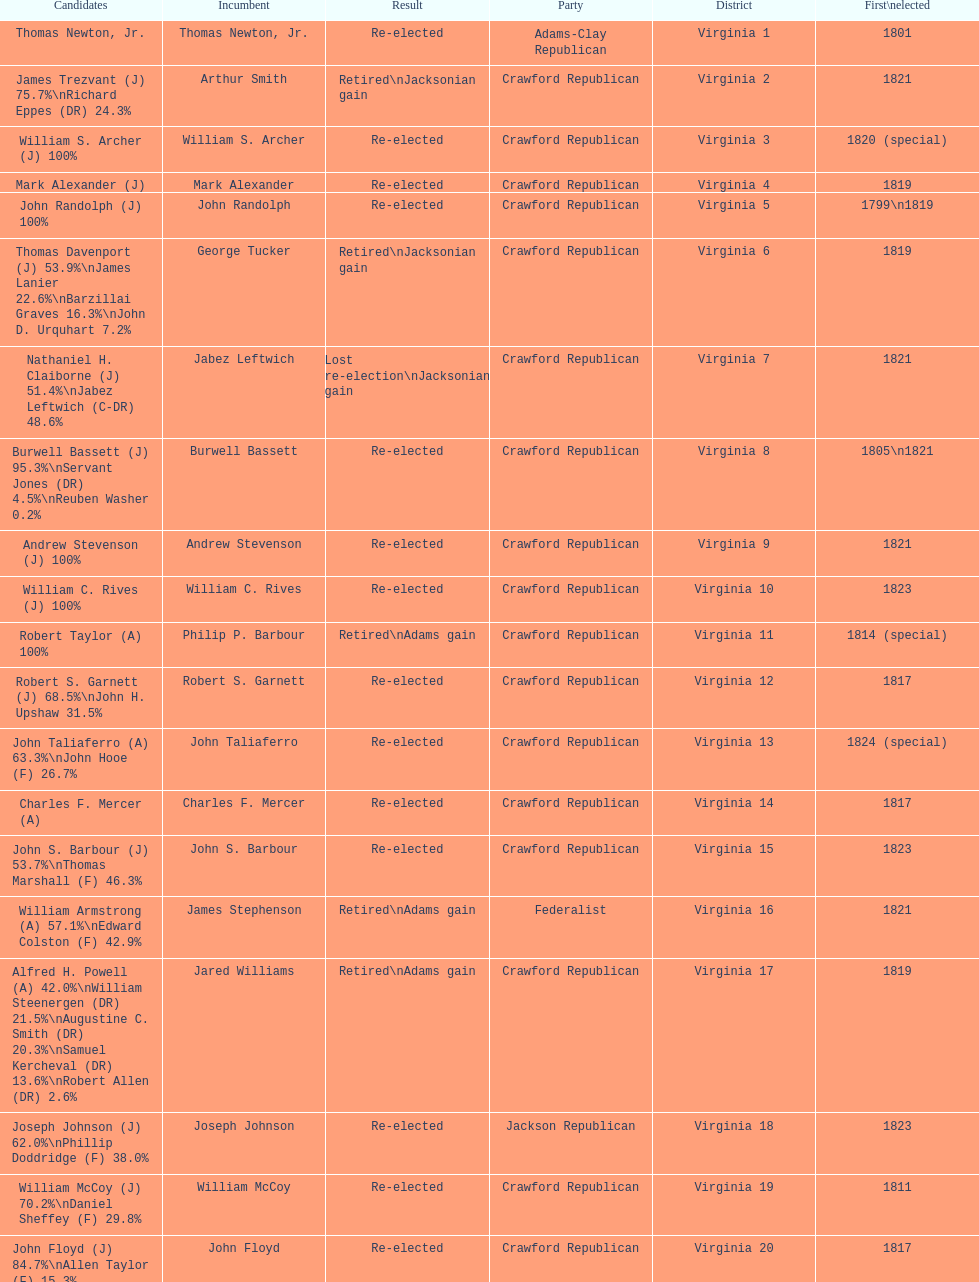What are the number of times re-elected is listed as the result? 15. 